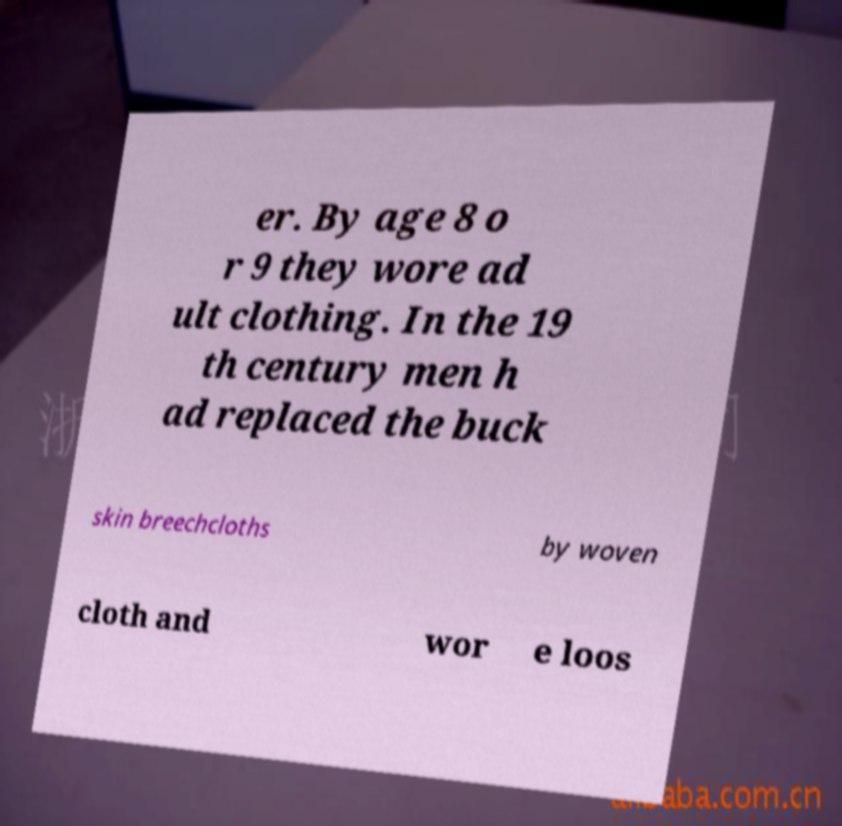Can you read and provide the text displayed in the image?This photo seems to have some interesting text. Can you extract and type it out for me? er. By age 8 o r 9 they wore ad ult clothing. In the 19 th century men h ad replaced the buck skin breechcloths by woven cloth and wor e loos 